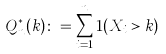<formula> <loc_0><loc_0><loc_500><loc_500>Q _ { n } ^ { * } ( k ) \colon = \sum _ { i = 1 } ^ { n } 1 ( X _ { i } > k )</formula> 